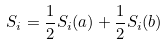<formula> <loc_0><loc_0><loc_500><loc_500>S _ { i } = \frac { 1 } { 2 } S _ { i } ( a ) + \frac { 1 } { 2 } S _ { i } ( b )</formula> 